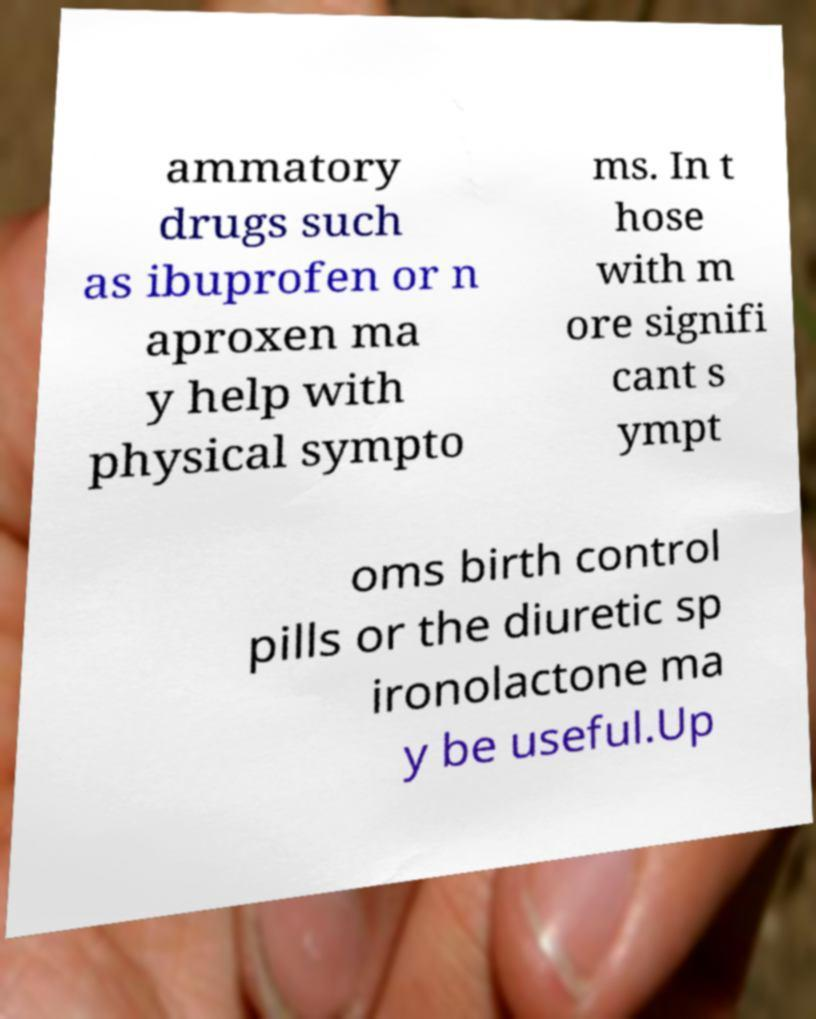Please read and relay the text visible in this image. What does it say? ammatory drugs such as ibuprofen or n aproxen ma y help with physical sympto ms. In t hose with m ore signifi cant s ympt oms birth control pills or the diuretic sp ironolactone ma y be useful.Up 